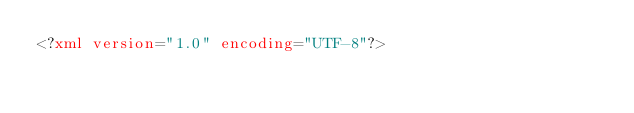Convert code to text. <code><loc_0><loc_0><loc_500><loc_500><_XML_><?xml version="1.0" encoding="UTF-8"?></code> 